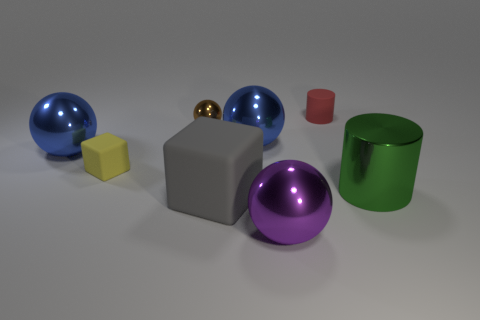Add 2 tiny rubber objects. How many objects exist? 10 Subtract all cylinders. How many objects are left? 6 Subtract all green metallic blocks. Subtract all large cubes. How many objects are left? 7 Add 1 blocks. How many blocks are left? 3 Add 7 green rubber cubes. How many green rubber cubes exist? 7 Subtract 2 blue balls. How many objects are left? 6 